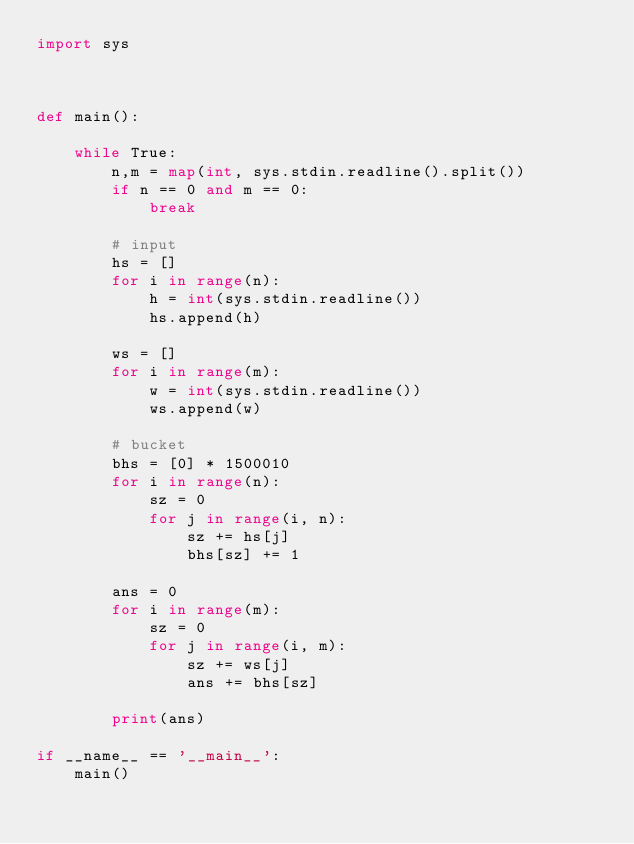<code> <loc_0><loc_0><loc_500><loc_500><_Python_>import sys



def main():
    
    while True:
        n,m = map(int, sys.stdin.readline().split())
        if n == 0 and m == 0:
            break

        # input
        hs = []
        for i in range(n):
            h = int(sys.stdin.readline())
            hs.append(h)

        ws = []
        for i in range(m):
            w = int(sys.stdin.readline())
            ws.append(w)

        # bucket
        bhs = [0] * 1500010
        for i in range(n):
            sz = 0
            for j in range(i, n):
                sz += hs[j]
                bhs[sz] += 1
        
        ans = 0
        for i in range(m):
            sz = 0
            for j in range(i, m):
                sz += ws[j]
                ans += bhs[sz]

        print(ans)

if __name__ == '__main__':
    main()</code> 